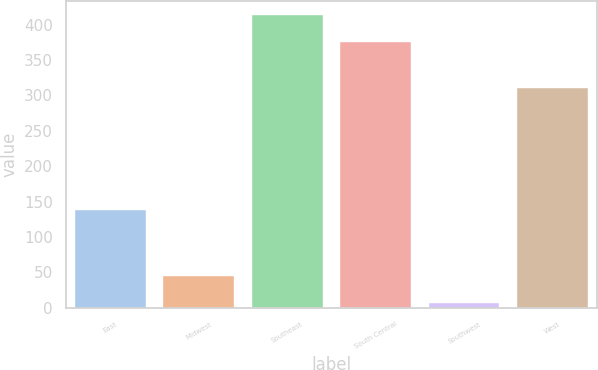<chart> <loc_0><loc_0><loc_500><loc_500><bar_chart><fcel>East<fcel>Midwest<fcel>Southeast<fcel>South Central<fcel>Southwest<fcel>West<nl><fcel>138.7<fcel>45.41<fcel>412.91<fcel>374.8<fcel>7.3<fcel>310.9<nl></chart> 